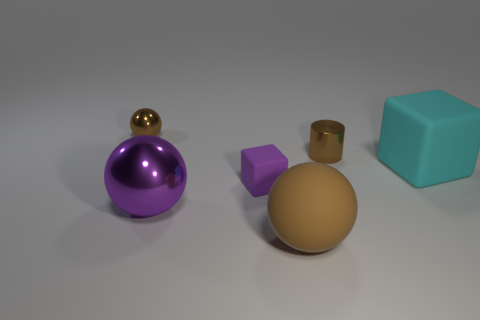Subtract all gray cubes. How many brown spheres are left? 2 Subtract 1 spheres. How many spheres are left? 2 Add 4 large blue metallic cubes. How many objects exist? 10 Subtract all cylinders. How many objects are left? 5 Subtract all large blue metallic blocks. Subtract all small purple objects. How many objects are left? 5 Add 5 large cyan rubber cubes. How many large cyan rubber cubes are left? 6 Add 3 big objects. How many big objects exist? 6 Subtract 0 blue spheres. How many objects are left? 6 